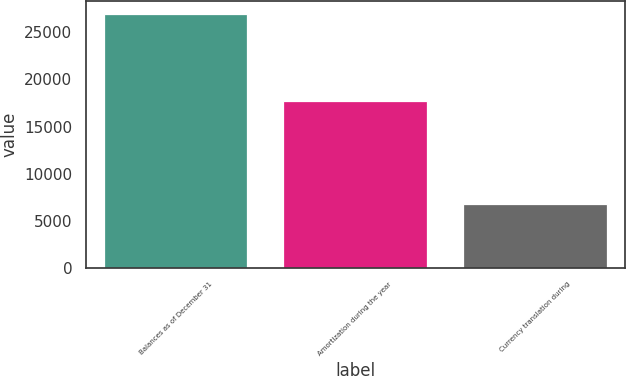<chart> <loc_0><loc_0><loc_500><loc_500><bar_chart><fcel>Balances as of December 31<fcel>Amortization during the year<fcel>Currency translation during<nl><fcel>26985<fcel>17700<fcel>6780<nl></chart> 